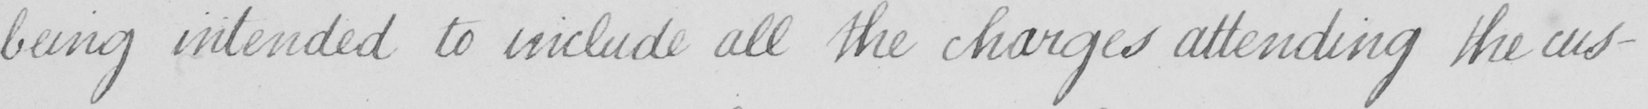Transcribe the text shown in this historical manuscript line. being intended to include all the charges attending the cus- 